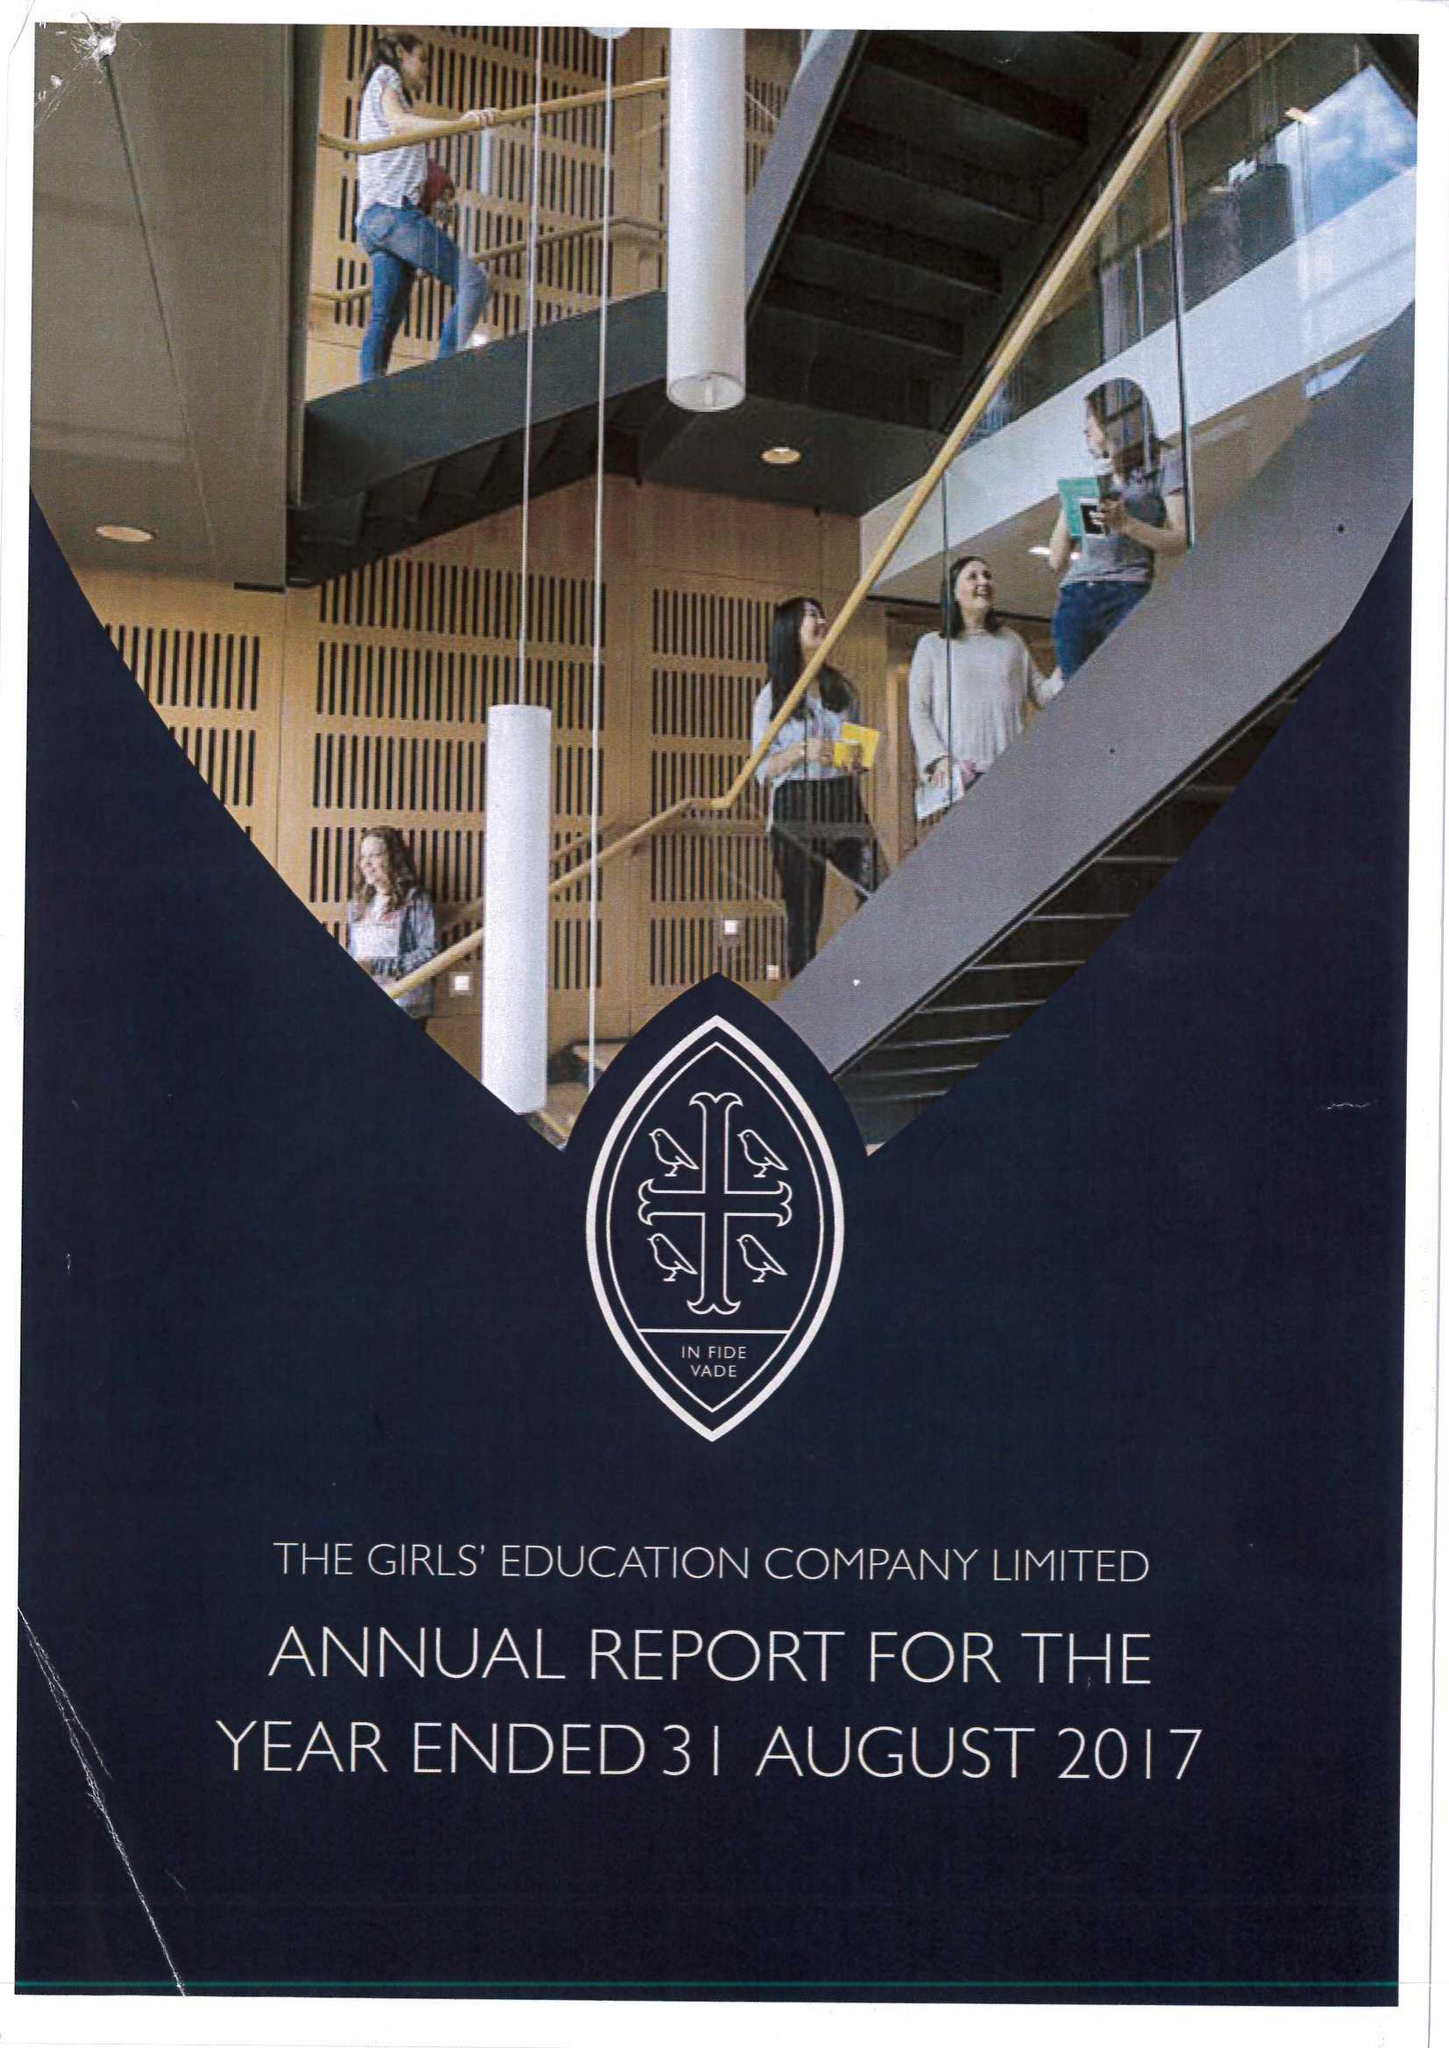What is the value for the address__post_town?
Answer the question using a single word or phrase. HIGH WYCOMBE 